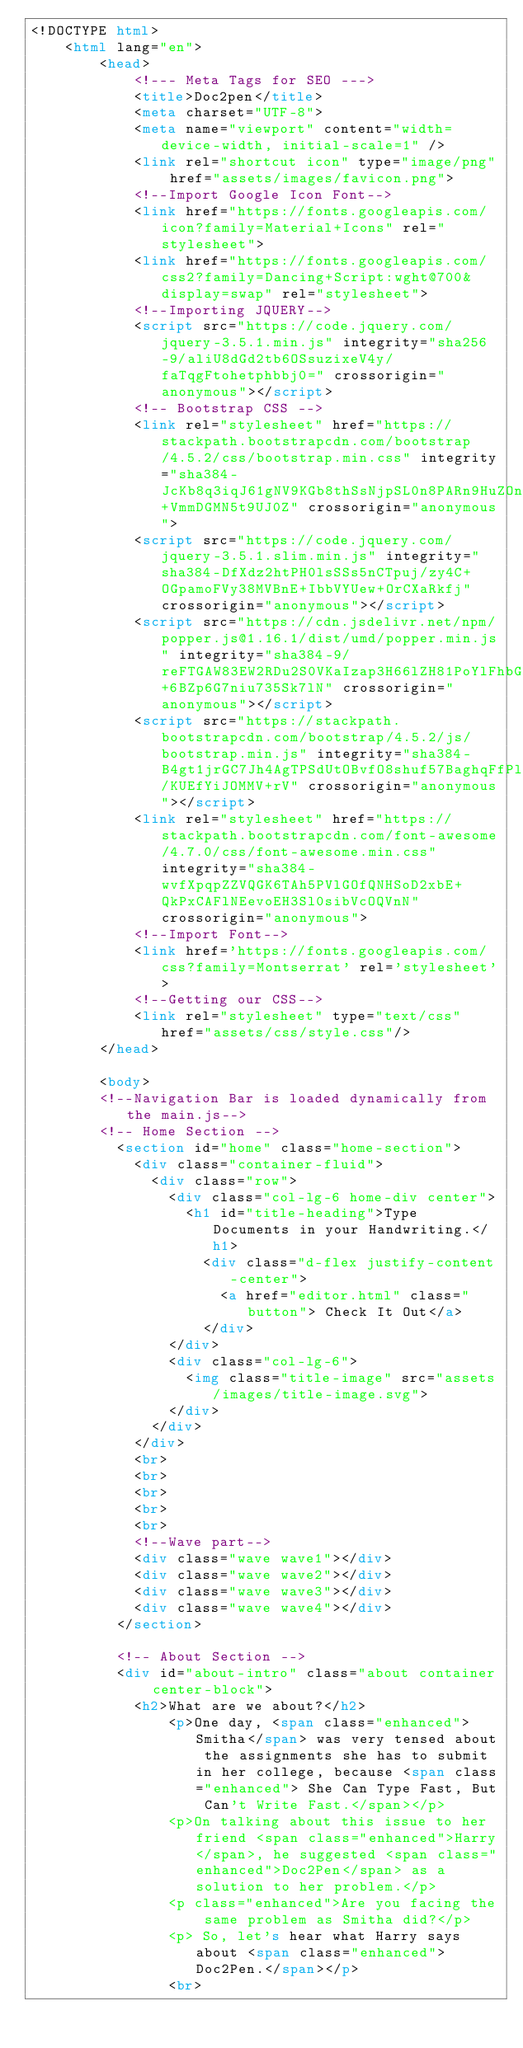<code> <loc_0><loc_0><loc_500><loc_500><_HTML_><!DOCTYPE html>
    <html lang="en">
        <head>
            <!--- Meta Tags for SEO --->
            <title>Doc2pen</title>
            <meta charset="UTF-8">
            <meta name="viewport" content="width=device-width, initial-scale=1" />
            <link rel="shortcut icon" type="image/png" href="assets/images/favicon.png">
            <!--Import Google Icon Font-->
            <link href="https://fonts.googleapis.com/icon?family=Material+Icons" rel="stylesheet">
            <link href="https://fonts.googleapis.com/css2?family=Dancing+Script:wght@700&display=swap" rel="stylesheet">
            <!--Importing JQUERY-->
            <script src="https://code.jquery.com/jquery-3.5.1.min.js" integrity="sha256-9/aliU8dGd2tb6OSsuzixeV4y/faTqgFtohetphbbj0=" crossorigin="anonymous"></script>
            <!-- Bootstrap CSS -->
            <link rel="stylesheet" href="https://stackpath.bootstrapcdn.com/bootstrap/4.5.2/css/bootstrap.min.css" integrity="sha384-JcKb8q3iqJ61gNV9KGb8thSsNjpSL0n8PARn9HuZOnIxN0hoP+VmmDGMN5t9UJ0Z" crossorigin="anonymous">
            <script src="https://code.jquery.com/jquery-3.5.1.slim.min.js" integrity="sha384-DfXdz2htPH0lsSSs5nCTpuj/zy4C+OGpamoFVy38MVBnE+IbbVYUew+OrCXaRkfj" crossorigin="anonymous"></script>
            <script src="https://cdn.jsdelivr.net/npm/popper.js@1.16.1/dist/umd/popper.min.js" integrity="sha384-9/reFTGAW83EW2RDu2S0VKaIzap3H66lZH81PoYlFhbGU+6BZp6G7niu735Sk7lN" crossorigin="anonymous"></script>
            <script src="https://stackpath.bootstrapcdn.com/bootstrap/4.5.2/js/bootstrap.min.js" integrity="sha384-B4gt1jrGC7Jh4AgTPSdUtOBvfO8shuf57BaghqFfPlYxofvL8/KUEfYiJOMMV+rV" crossorigin="anonymous"></script>
            <link rel="stylesheet" href="https://stackpath.bootstrapcdn.com/font-awesome/4.7.0/css/font-awesome.min.css" integrity="sha384-wvfXpqpZZVQGK6TAh5PVlGOfQNHSoD2xbE+QkPxCAFlNEevoEH3Sl0sibVcOQVnN" crossorigin="anonymous">
            <!--Import Font-->
            <link href='https://fonts.googleapis.com/css?family=Montserrat' rel='stylesheet'>
            <!--Getting our CSS-->
            <link rel="stylesheet" type="text/css" href="assets/css/style.css"/>
        </head>
        
        <body>
        <!--Navigation Bar is loaded dynamically from the main.js-->
        <!-- Home Section -->
          <section id="home" class="home-section">
            <div class="container-fluid">
              <div class="row"> 
                <div class="col-lg-6 home-div center">
                  <h1 id="title-heading">Type Documents in your Handwriting.</h1>
                    <div class="d-flex justify-content-center">
                      <a href="editor.html" class="button"> Check It Out</a>
                    </div>
                </div>
                <div class="col-lg-6">
                  <img class="title-image" src="assets/images/title-image.svg">
                </div>
              </div>
            </div>
            <br>
            <br>
            <br>
            <br>
            <br>
            <!--Wave part-->
            <div class="wave wave1"></div>
            <div class="wave wave2"></div>
            <div class="wave wave3"></div>
            <div class="wave wave4"></div>
          </section>
          
          <!-- About Section -->
          <div id="about-intro" class="about container center-block">
            <h2>What are we about?</h2>
                <p>One day, <span class="enhanced">Smitha</span> was very tensed about the assignments she has to submit in her college, because <span class="enhanced"> She Can Type Fast, But Can't Write Fast.</span></p>
                <p>On talking about this issue to her friend <span class="enhanced">Harry</span>, he suggested <span class="enhanced">Doc2Pen</span> as a solution to her problem.</p>
                <p class="enhanced">Are you facing the same problem as Smitha did?</p>
                <p> So, let's hear what Harry says about <span class="enhanced">Doc2Pen.</span></p>
                <br></code> 